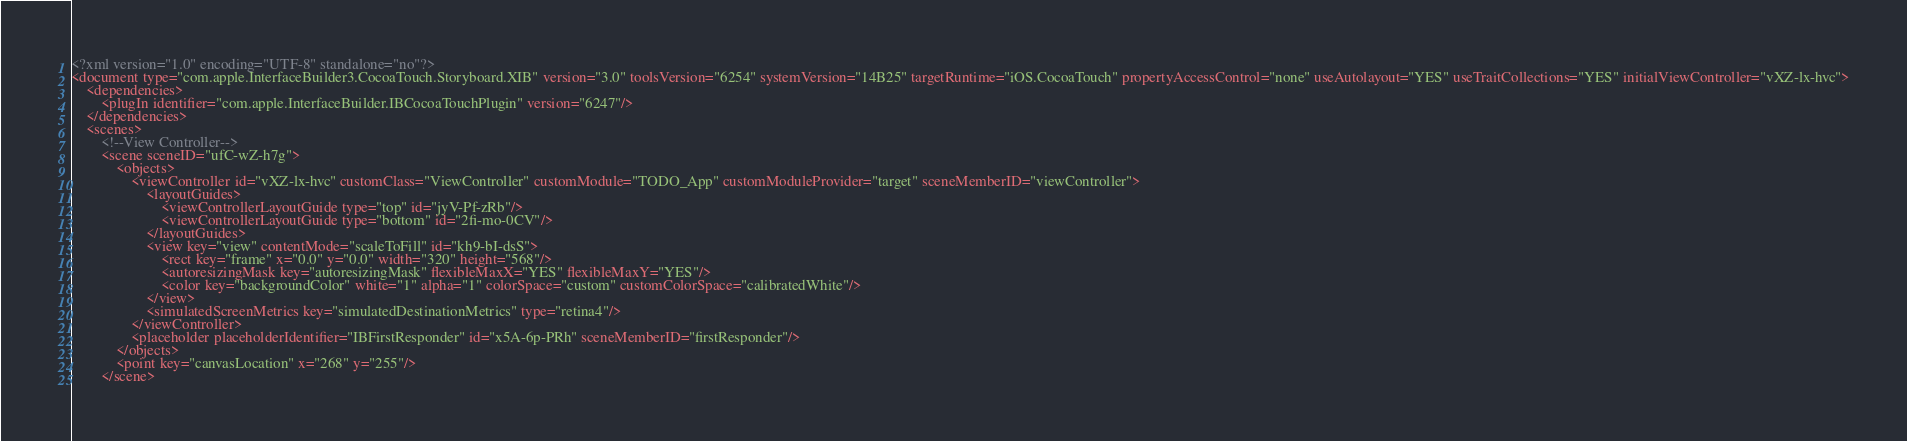Convert code to text. <code><loc_0><loc_0><loc_500><loc_500><_XML_><?xml version="1.0" encoding="UTF-8" standalone="no"?>
<document type="com.apple.InterfaceBuilder3.CocoaTouch.Storyboard.XIB" version="3.0" toolsVersion="6254" systemVersion="14B25" targetRuntime="iOS.CocoaTouch" propertyAccessControl="none" useAutolayout="YES" useTraitCollections="YES" initialViewController="vXZ-lx-hvc">
    <dependencies>
        <plugIn identifier="com.apple.InterfaceBuilder.IBCocoaTouchPlugin" version="6247"/>
    </dependencies>
    <scenes>
        <!--View Controller-->
        <scene sceneID="ufC-wZ-h7g">
            <objects>
                <viewController id="vXZ-lx-hvc" customClass="ViewController" customModule="TODO_App" customModuleProvider="target" sceneMemberID="viewController">
                    <layoutGuides>
                        <viewControllerLayoutGuide type="top" id="jyV-Pf-zRb"/>
                        <viewControllerLayoutGuide type="bottom" id="2fi-mo-0CV"/>
                    </layoutGuides>
                    <view key="view" contentMode="scaleToFill" id="kh9-bI-dsS">
                        <rect key="frame" x="0.0" y="0.0" width="320" height="568"/>
                        <autoresizingMask key="autoresizingMask" flexibleMaxX="YES" flexibleMaxY="YES"/>
                        <color key="backgroundColor" white="1" alpha="1" colorSpace="custom" customColorSpace="calibratedWhite"/>
                    </view>
                    <simulatedScreenMetrics key="simulatedDestinationMetrics" type="retina4"/>
                </viewController>
                <placeholder placeholderIdentifier="IBFirstResponder" id="x5A-6p-PRh" sceneMemberID="firstResponder"/>
            </objects>
            <point key="canvasLocation" x="268" y="255"/>
        </scene></code> 